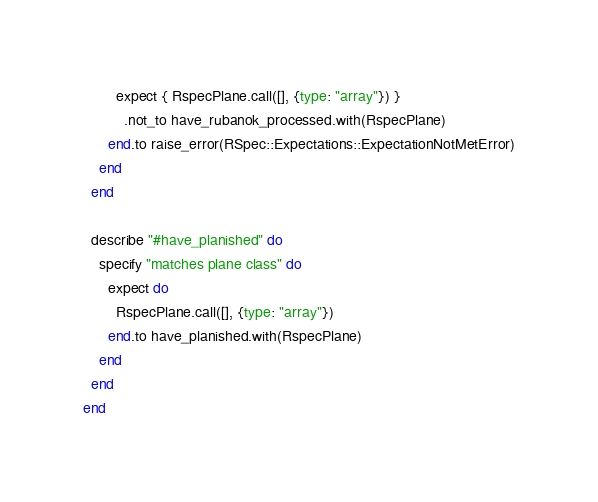<code> <loc_0><loc_0><loc_500><loc_500><_Ruby_>        expect { RspecPlane.call([], {type: "array"}) }
          .not_to have_rubanok_processed.with(RspecPlane)
      end.to raise_error(RSpec::Expectations::ExpectationNotMetError)
    end
  end

  describe "#have_planished" do
    specify "matches plane class" do
      expect do
        RspecPlane.call([], {type: "array"})
      end.to have_planished.with(RspecPlane)
    end
  end
end
</code> 